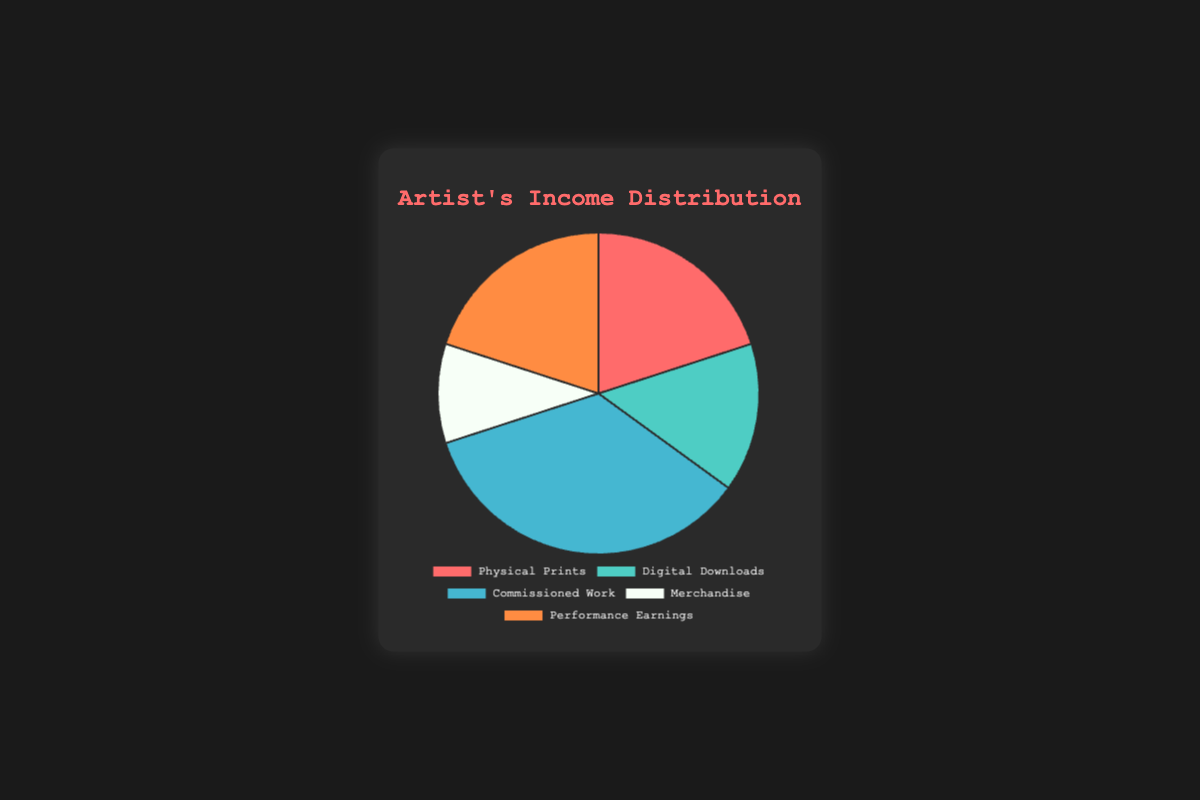Which category has the highest income? By looking at the pie chart, "Commissioned Work" is the largest segment visually. It accounts for 35% of the total income.
Answer: Commissioned Work How much is the total income from Physical Prints and Performance Earnings together? Sum the percentages of "Physical Prints" (20%) and "Performance Earnings" (20%). The total is 20% + 20% = 40%.
Answer: 40% Is the income from Merchandise greater than Digital Downloads? Compare the segment sizes of "Merchandise" and "Digital Downloads." "Merchandise" is 10% and "Digital Downloads" is 15%, so "Merchandise" is not greater.
Answer: No What is the difference in income between Digital Downloads and Physical Prints? The percentage for "Digital Downloads" is 15% and for "Physical Prints" is 20%. The difference is 20% - 15% = 5%.
Answer: 5% What percentage of the total income comes from Performance Earnings? From the pie chart, we can see that "Performance Earnings" accounts for 20% of the total income.
Answer: 20% Which two categories have an equal income percentage? Looking at the pie chart, "Physical Prints" and "Performance Earnings" both account for 20% of the total income.
Answer: Physical Prints and Performance Earnings What is the sum of income from Commissioned Work and Merchandise? Sum the percentages of "Commissioned Work" (35%) and "Merchandise" (10%). The total is 35% + 10% = 45%.
Answer: 45% Is the income from Digital Downloads less than Physical Prints and Merchandise combined? Combine the percentages of "Physical Prints" (20%) and "Merchandise" (10%). The total is 20% + 10% = 30%. Since 30% is more than the 15% from "Digital Downloads," the income from Digital Downloads is indeed less.
Answer: Yes 